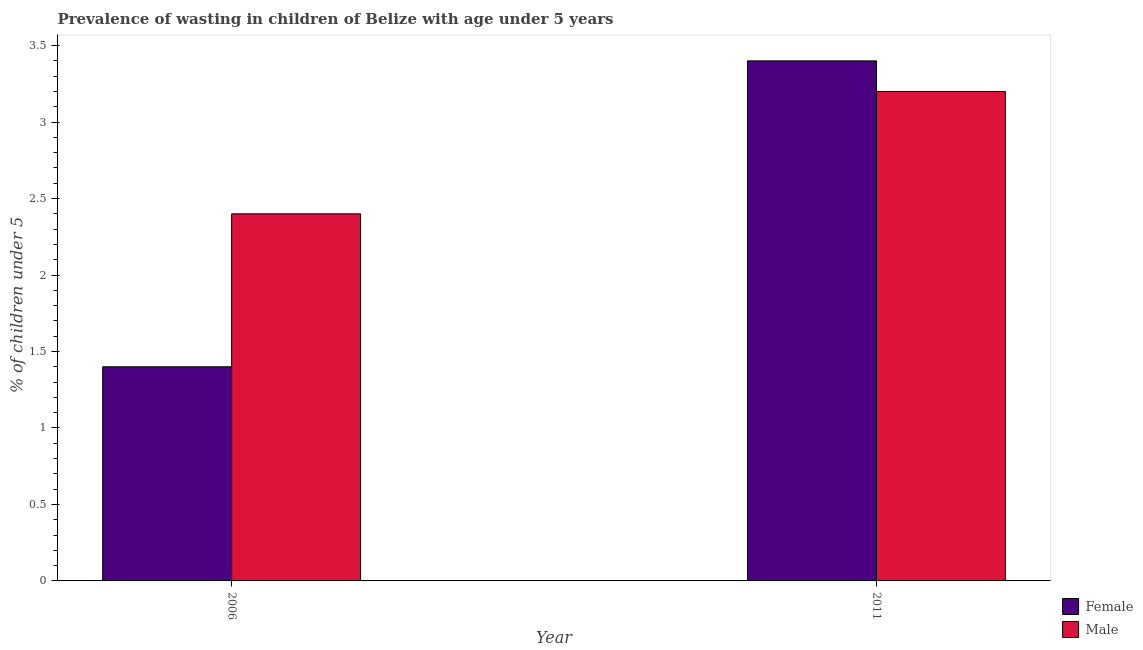How many different coloured bars are there?
Provide a succinct answer. 2. How many groups of bars are there?
Keep it short and to the point. 2. How many bars are there on the 1st tick from the left?
Your answer should be very brief. 2. In how many cases, is the number of bars for a given year not equal to the number of legend labels?
Keep it short and to the point. 0. What is the percentage of undernourished female children in 2006?
Keep it short and to the point. 1.4. Across all years, what is the maximum percentage of undernourished male children?
Provide a succinct answer. 3.2. Across all years, what is the minimum percentage of undernourished female children?
Your answer should be compact. 1.4. In which year was the percentage of undernourished male children maximum?
Provide a succinct answer. 2011. In which year was the percentage of undernourished male children minimum?
Offer a very short reply. 2006. What is the total percentage of undernourished male children in the graph?
Provide a short and direct response. 5.6. What is the difference between the percentage of undernourished male children in 2006 and that in 2011?
Keep it short and to the point. -0.8. What is the difference between the percentage of undernourished female children in 2011 and the percentage of undernourished male children in 2006?
Give a very brief answer. 2. What is the average percentage of undernourished female children per year?
Offer a terse response. 2.4. In the year 2006, what is the difference between the percentage of undernourished male children and percentage of undernourished female children?
Keep it short and to the point. 0. In how many years, is the percentage of undernourished female children greater than 1.9 %?
Provide a succinct answer. 1. What is the ratio of the percentage of undernourished female children in 2006 to that in 2011?
Provide a short and direct response. 0.41. Is the percentage of undernourished male children in 2006 less than that in 2011?
Provide a succinct answer. Yes. In how many years, is the percentage of undernourished male children greater than the average percentage of undernourished male children taken over all years?
Your answer should be compact. 1. What does the 2nd bar from the left in 2006 represents?
Provide a succinct answer. Male. Are all the bars in the graph horizontal?
Your response must be concise. No. Does the graph contain any zero values?
Provide a short and direct response. No. Does the graph contain grids?
Your response must be concise. No. How many legend labels are there?
Offer a terse response. 2. What is the title of the graph?
Offer a very short reply. Prevalence of wasting in children of Belize with age under 5 years. What is the label or title of the X-axis?
Your response must be concise. Year. What is the label or title of the Y-axis?
Keep it short and to the point.  % of children under 5. What is the  % of children under 5 in Female in 2006?
Provide a short and direct response. 1.4. What is the  % of children under 5 in Male in 2006?
Ensure brevity in your answer.  2.4. What is the  % of children under 5 in Female in 2011?
Make the answer very short. 3.4. What is the  % of children under 5 of Male in 2011?
Provide a short and direct response. 3.2. Across all years, what is the maximum  % of children under 5 in Female?
Your answer should be very brief. 3.4. Across all years, what is the maximum  % of children under 5 of Male?
Your answer should be compact. 3.2. Across all years, what is the minimum  % of children under 5 in Female?
Make the answer very short. 1.4. Across all years, what is the minimum  % of children under 5 of Male?
Give a very brief answer. 2.4. What is the difference between the  % of children under 5 of Female in 2006 and that in 2011?
Your answer should be compact. -2. What is the difference between the  % of children under 5 in Female in 2006 and the  % of children under 5 in Male in 2011?
Your answer should be very brief. -1.8. What is the average  % of children under 5 in Male per year?
Your answer should be compact. 2.8. In the year 2006, what is the difference between the  % of children under 5 of Female and  % of children under 5 of Male?
Ensure brevity in your answer.  -1. What is the ratio of the  % of children under 5 of Female in 2006 to that in 2011?
Provide a short and direct response. 0.41. What is the difference between the highest and the second highest  % of children under 5 in Female?
Provide a short and direct response. 2. 